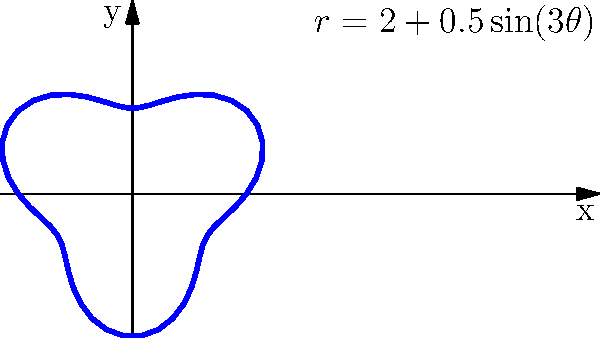The polar curve $r = 2 + 0.5\sin(3\theta)$ represents the growth pattern of a spiral aloe plant. What is the maximum radial distance from the center of the plant to its outermost point, and at which angle(s) does this occur? To find the maximum radial distance and the corresponding angle(s), we need to follow these steps:

1. The radial distance is given by the function $r = 2 + 0.5\sin(3\theta)$.

2. The maximum value of $\sin(3\theta)$ is 1, which occurs when $3\theta = \frac{\pi}{2} + 2\pi n$, where $n$ is an integer.

3. Solving for $\theta$:
   $\theta = \frac{\pi}{6} + \frac{2\pi n}{3}$, where $n = 0, 1, 2, ...$

4. The maximum radial distance occurs when $\sin(3\theta) = 1$:
   $r_{max} = 2 + 0.5(1) = 2.5$

5. The first angle (in the first revolution) where this maximum occurs is when $n = 0$:
   $\theta = \frac{\pi}{6} \approx 0.52$ radians or $30°$

6. Subsequent maxima occur at angles:
   $\frac{\pi}{6} + \frac{2\pi}{3} \approx 2.62$ radians or $150°$
   $\frac{\pi}{6} + \frac{4\pi}{3} \approx 4.71$ radians or $270°$

Therefore, the maximum radial distance is 2.5 units, occurring at angles $30°$, $150°$, and $270°$ in the first full revolution.
Answer: 2.5 units; at $30°$, $150°$, and $270°$ 